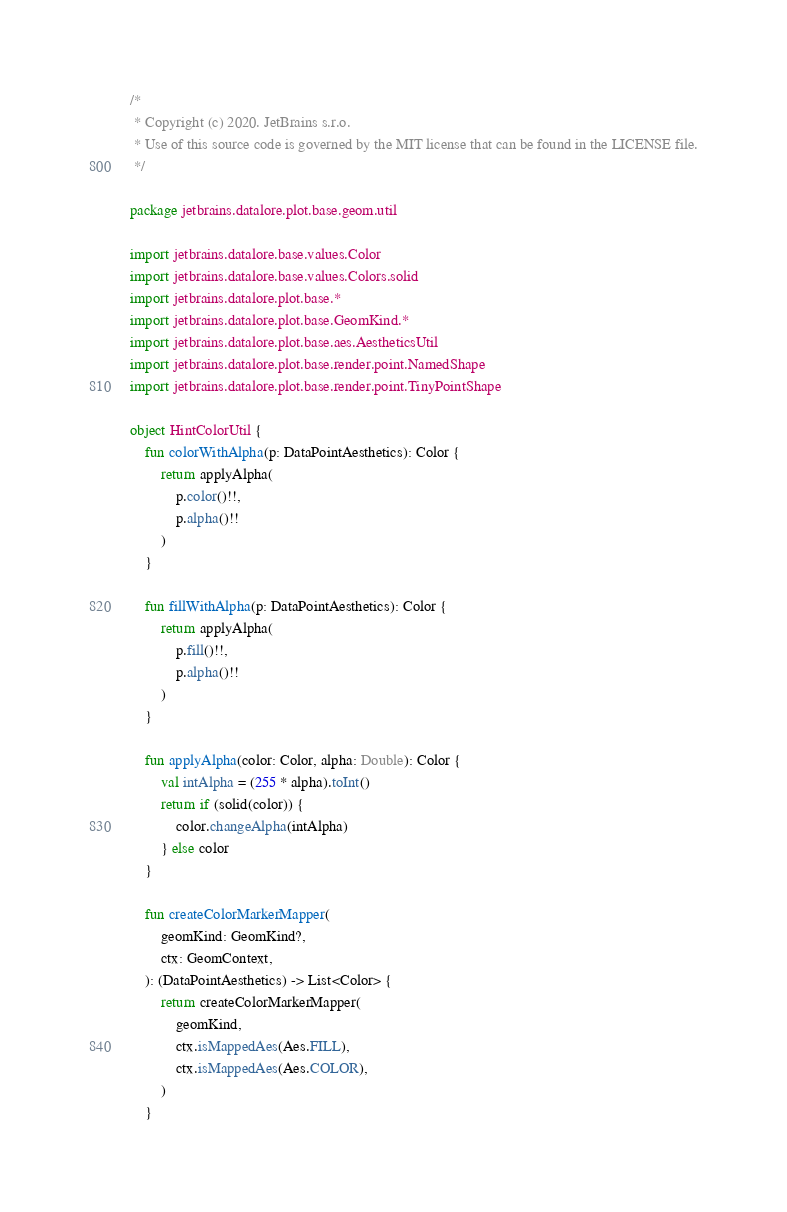<code> <loc_0><loc_0><loc_500><loc_500><_Kotlin_>/*
 * Copyright (c) 2020. JetBrains s.r.o.
 * Use of this source code is governed by the MIT license that can be found in the LICENSE file.
 */

package jetbrains.datalore.plot.base.geom.util

import jetbrains.datalore.base.values.Color
import jetbrains.datalore.base.values.Colors.solid
import jetbrains.datalore.plot.base.*
import jetbrains.datalore.plot.base.GeomKind.*
import jetbrains.datalore.plot.base.aes.AestheticsUtil
import jetbrains.datalore.plot.base.render.point.NamedShape
import jetbrains.datalore.plot.base.render.point.TinyPointShape

object HintColorUtil {
    fun colorWithAlpha(p: DataPointAesthetics): Color {
        return applyAlpha(
            p.color()!!,
            p.alpha()!!
        )
    }

    fun fillWithAlpha(p: DataPointAesthetics): Color {
        return applyAlpha(
            p.fill()!!,
            p.alpha()!!
        )
    }

    fun applyAlpha(color: Color, alpha: Double): Color {
        val intAlpha = (255 * alpha).toInt()
        return if (solid(color)) {
            color.changeAlpha(intAlpha)
        } else color
    }

    fun createColorMarkerMapper(
        geomKind: GeomKind?,
        ctx: GeomContext,
    ): (DataPointAesthetics) -> List<Color> {
        return createColorMarkerMapper(
            geomKind,
            ctx.isMappedAes(Aes.FILL),
            ctx.isMappedAes(Aes.COLOR),
        )
    }
</code> 